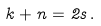Convert formula to latex. <formula><loc_0><loc_0><loc_500><loc_500>k + n = 2 s \, .</formula> 